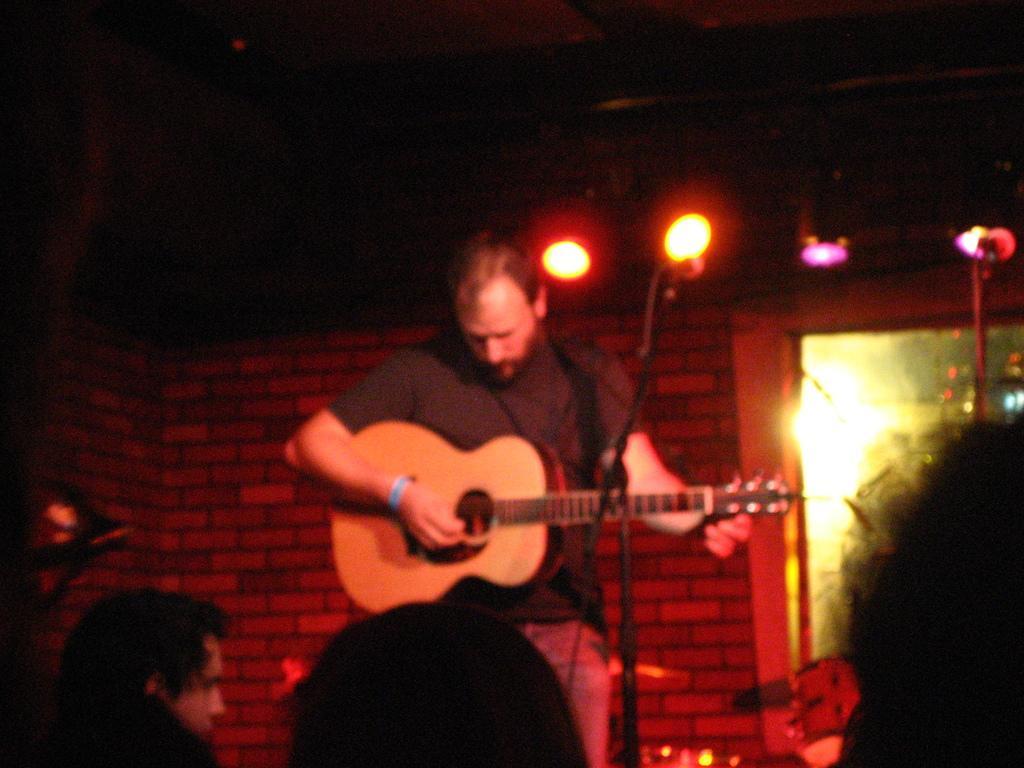How would you summarize this image in a sentence or two? Here we have a man who is holding a guitar in his hand and playing a guitar in front of group of people. There is a microphone over here and behind the man we can see a brick of wall and on the top right of the image we can see stage lights and the man is wearing a black t-shirt. 